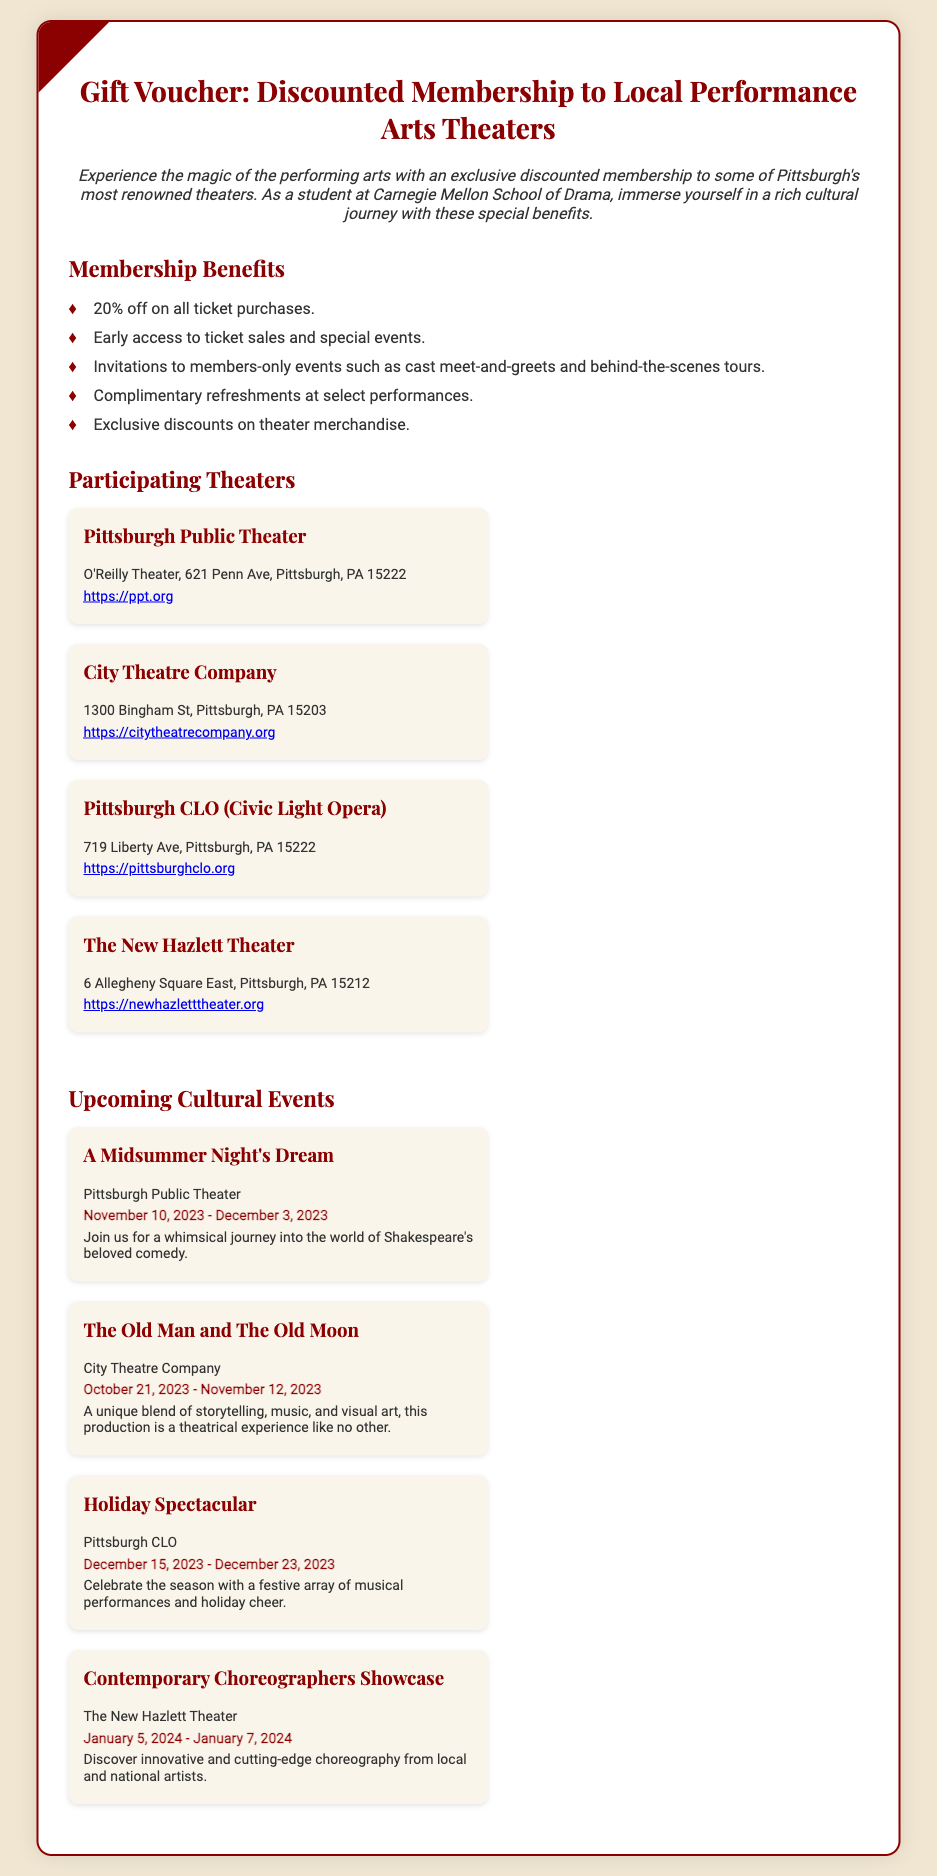What is the discount percentage offered on ticket purchases? The document states a 20% discount on all ticket purchases as part of the membership benefits.
Answer: 20% Which theater is located at 621 Penn Ave? The document lists Pittsburgh Public Theater as the theater located at 621 Penn Ave, Pittsburgh, PA 15222.
Answer: Pittsburgh Public Theater What is the date range for "A Midsummer Night's Dream"? The event "A Midsummer Night's Dream" is scheduled from November 10, 2023 to December 3, 2023, as specified in the events section.
Answer: November 10, 2023 - December 3, 2023 What type of events can members attend? Members are invited to attend members-only events like cast meet-and-greets and behind-the-scenes tours, as detailed in the membership benefits.
Answer: Cast meet-and-greets and behind-the-scenes tours Which theater hosts the "Holiday Spectacular"? The "Holiday Spectacular" event is hosted by Pittsburgh CLO, as noted in the cultural events schedule.
Answer: Pittsburgh CLO What is offered at select performances for members? The document mentions complimentary refreshments at select performances as a benefit for members.
Answer: Complimentary refreshments 